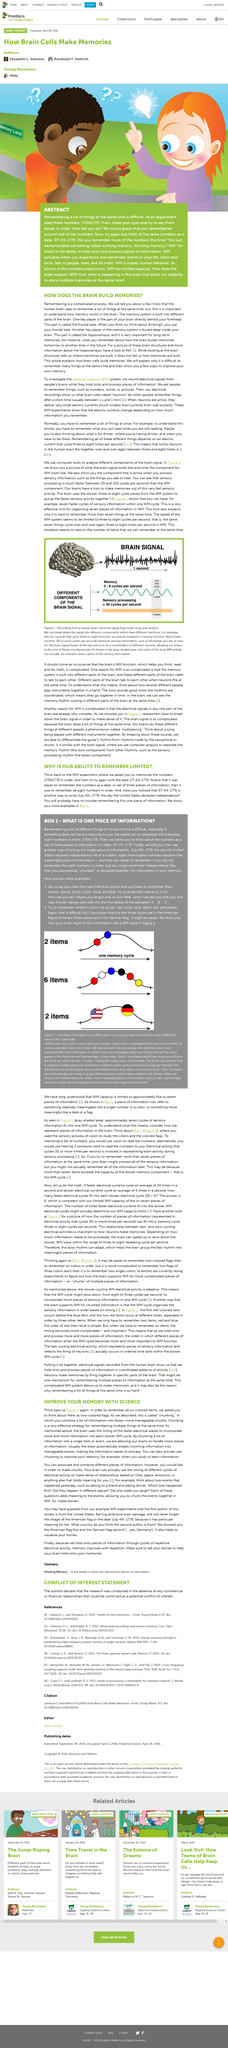Identify some key points in this picture. The United States declared its independence on July 4th, 1776. The date 07-04-1776 is more easily remembered than 07041776, according to research. The ease of remembering information is influenced by the organization of the information, with certain orders being more readily remembered than others. For example, it is easier to remember a sequence of numbers as a specific date or as a set of three pieces of information, rather than remembering all eight numbers in order. 